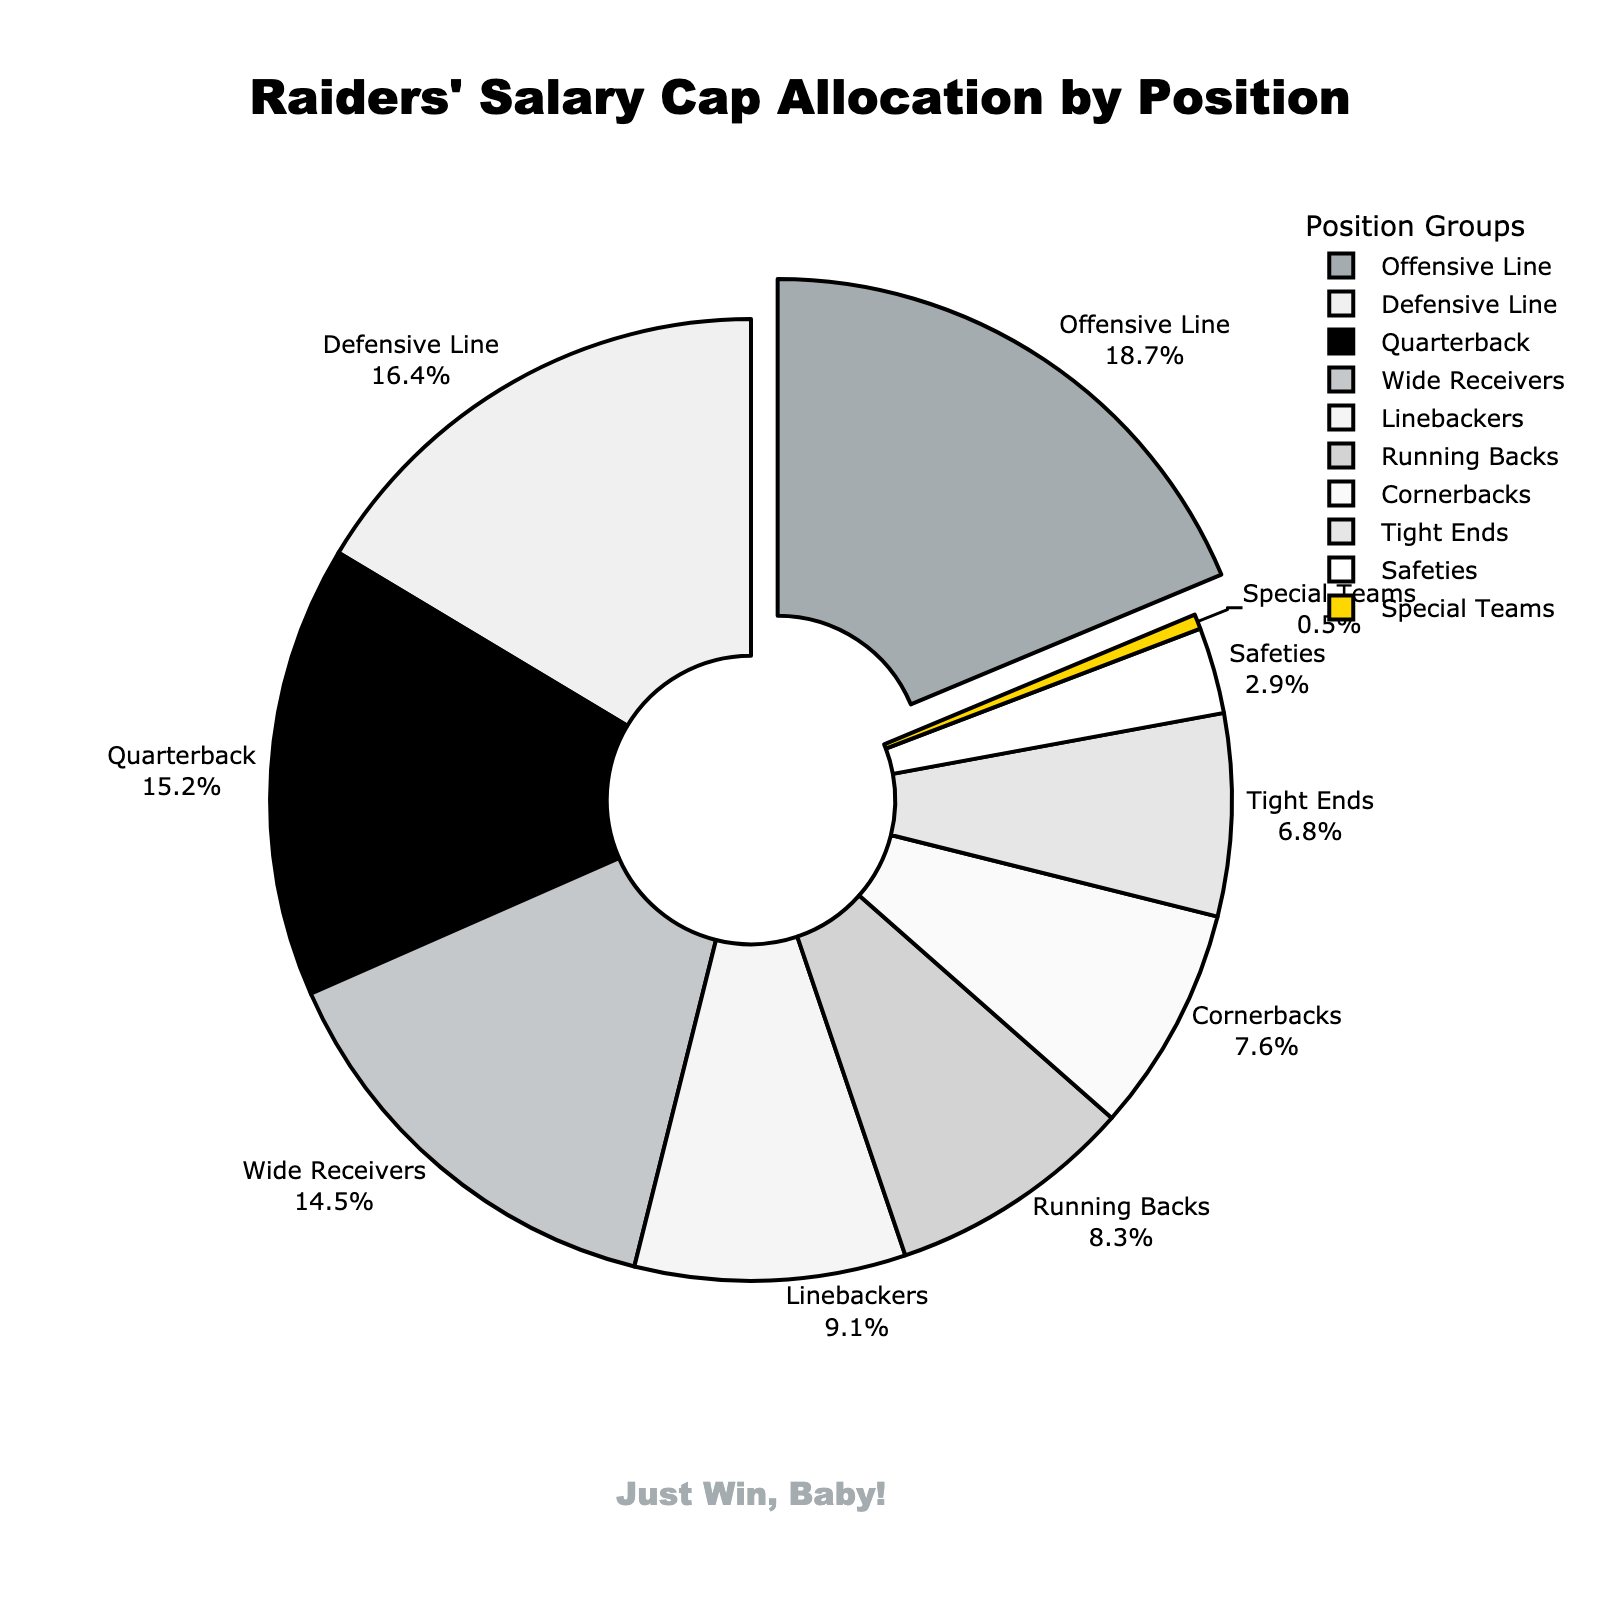What position group gets the largest percentage of the Raiders' salary cap? The position group with the largest percentage can be seen as the segment with the largest slice and the label showing the highest percentage value. The 'Offensive Line' has the largest percentage at 18.7%.
Answer: Offensive Line Which position groups combined take up more than 30% of the salary cap? To find the combined total of more than 30%, we need to identify the position groups and sum their percentages until it exceeds 30%. The first two groups, 'Offensive Line' (18.7%) and 'Quarterback' (15.2%), sum up to 33.9%.
Answer: Offensive Line and Quarterback How much more of the salary cap is allocated to Defensive Line compared to Safeties? The percentage for 'Defensive Line' is 16.4% and for 'Safeties' is 2.9%. Subtract the smaller value from the larger one: 16.4% - 2.9% = 13.5%.
Answer: 13.5% Which position group receives the least allocation of the salary cap, and what percentage do they get? The segment with the smallest slice and the label showing the lowest percentage is the 'Special Teams' with a 0.5% allocation.
Answer: Special Teams, 0.5% Which two position groups have a combined salary cap allocation of more than 15% but less than 20%? We need to identify two groups whose summed percentage falls between 15% and 20%. 'Running Backs' (8.3%) and 'Linebackers' (9.1%) combined have a total of 17.4%, which fits the criteria.
Answer: Running Backs and Linebackers What is the average percentage of the salary cap allocation for the position groups? Sum all percentages and divide by the number of position groups: (15.2 + 18.7 + 14.5 + 8.3 + 6.8 + 16.4 + 9.1 + 7.6 + 2.9 + 0.5)/10 = 100/10 = 10%.
Answer: 10% Which position group has the second smallest salary cap allocation? The segment with the second smallest slice, next to the smallest one, is the 'Safeties' with a 2.9% allocation.
Answer: Safeties 